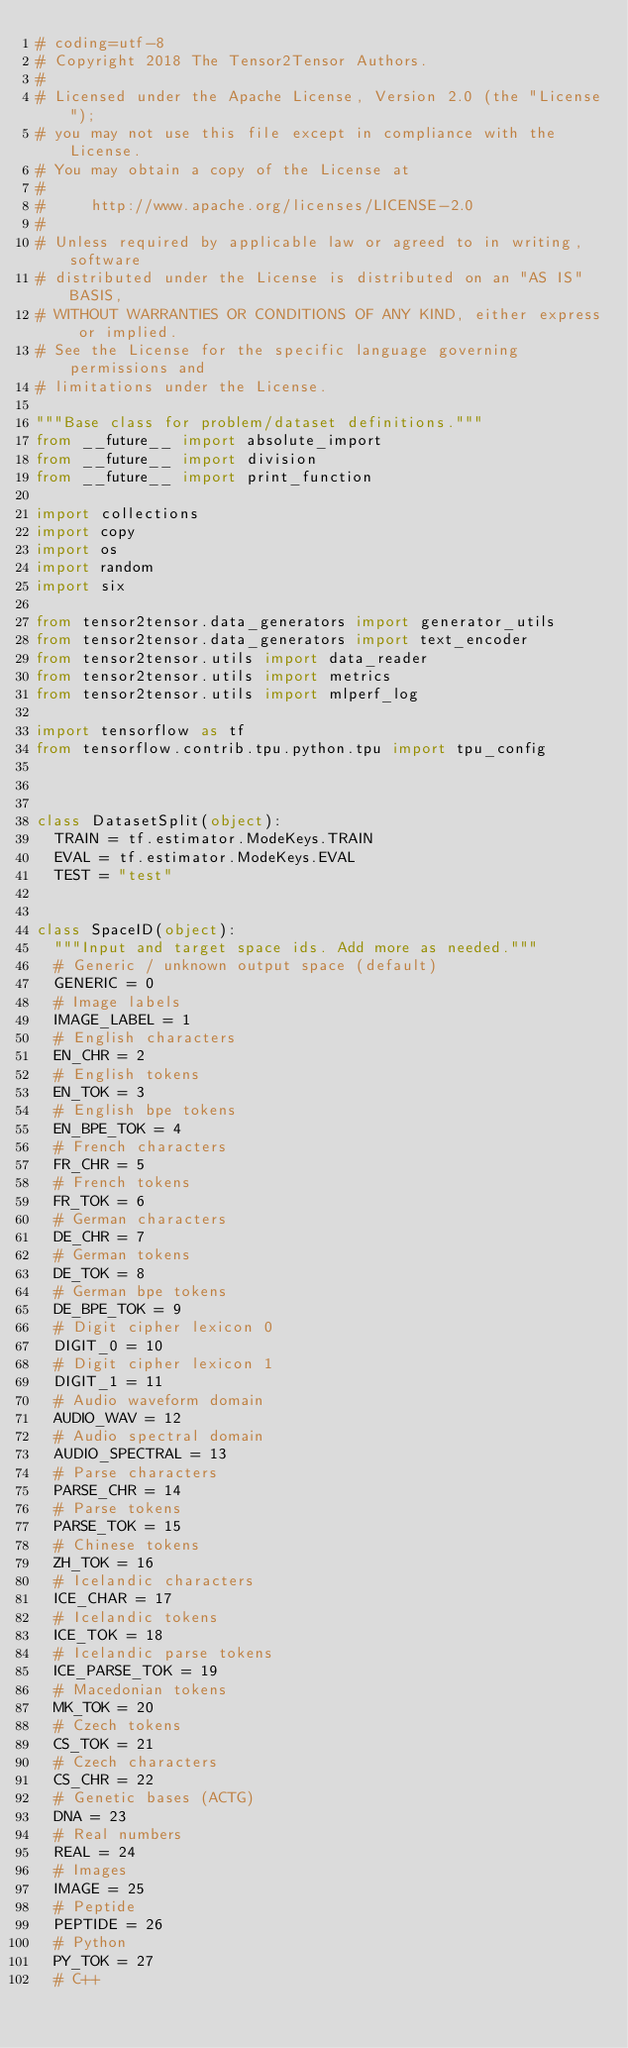<code> <loc_0><loc_0><loc_500><loc_500><_Python_># coding=utf-8
# Copyright 2018 The Tensor2Tensor Authors.
#
# Licensed under the Apache License, Version 2.0 (the "License");
# you may not use this file except in compliance with the License.
# You may obtain a copy of the License at
#
#     http://www.apache.org/licenses/LICENSE-2.0
#
# Unless required by applicable law or agreed to in writing, software
# distributed under the License is distributed on an "AS IS" BASIS,
# WITHOUT WARRANTIES OR CONDITIONS OF ANY KIND, either express or implied.
# See the License for the specific language governing permissions and
# limitations under the License.

"""Base class for problem/dataset definitions."""
from __future__ import absolute_import
from __future__ import division
from __future__ import print_function

import collections
import copy
import os
import random
import six

from tensor2tensor.data_generators import generator_utils
from tensor2tensor.data_generators import text_encoder
from tensor2tensor.utils import data_reader
from tensor2tensor.utils import metrics
from tensor2tensor.utils import mlperf_log

import tensorflow as tf
from tensorflow.contrib.tpu.python.tpu import tpu_config



class DatasetSplit(object):
  TRAIN = tf.estimator.ModeKeys.TRAIN
  EVAL = tf.estimator.ModeKeys.EVAL
  TEST = "test"


class SpaceID(object):
  """Input and target space ids. Add more as needed."""
  # Generic / unknown output space (default)
  GENERIC = 0
  # Image labels
  IMAGE_LABEL = 1
  # English characters
  EN_CHR = 2
  # English tokens
  EN_TOK = 3
  # English bpe tokens
  EN_BPE_TOK = 4
  # French characters
  FR_CHR = 5
  # French tokens
  FR_TOK = 6
  # German characters
  DE_CHR = 7
  # German tokens
  DE_TOK = 8
  # German bpe tokens
  DE_BPE_TOK = 9
  # Digit cipher lexicon 0
  DIGIT_0 = 10
  # Digit cipher lexicon 1
  DIGIT_1 = 11
  # Audio waveform domain
  AUDIO_WAV = 12
  # Audio spectral domain
  AUDIO_SPECTRAL = 13
  # Parse characters
  PARSE_CHR = 14
  # Parse tokens
  PARSE_TOK = 15
  # Chinese tokens
  ZH_TOK = 16
  # Icelandic characters
  ICE_CHAR = 17
  # Icelandic tokens
  ICE_TOK = 18
  # Icelandic parse tokens
  ICE_PARSE_TOK = 19
  # Macedonian tokens
  MK_TOK = 20
  # Czech tokens
  CS_TOK = 21
  # Czech characters
  CS_CHR = 22
  # Genetic bases (ACTG)
  DNA = 23
  # Real numbers
  REAL = 24
  # Images
  IMAGE = 25
  # Peptide
  PEPTIDE = 26
  # Python
  PY_TOK = 27
  # C++</code> 